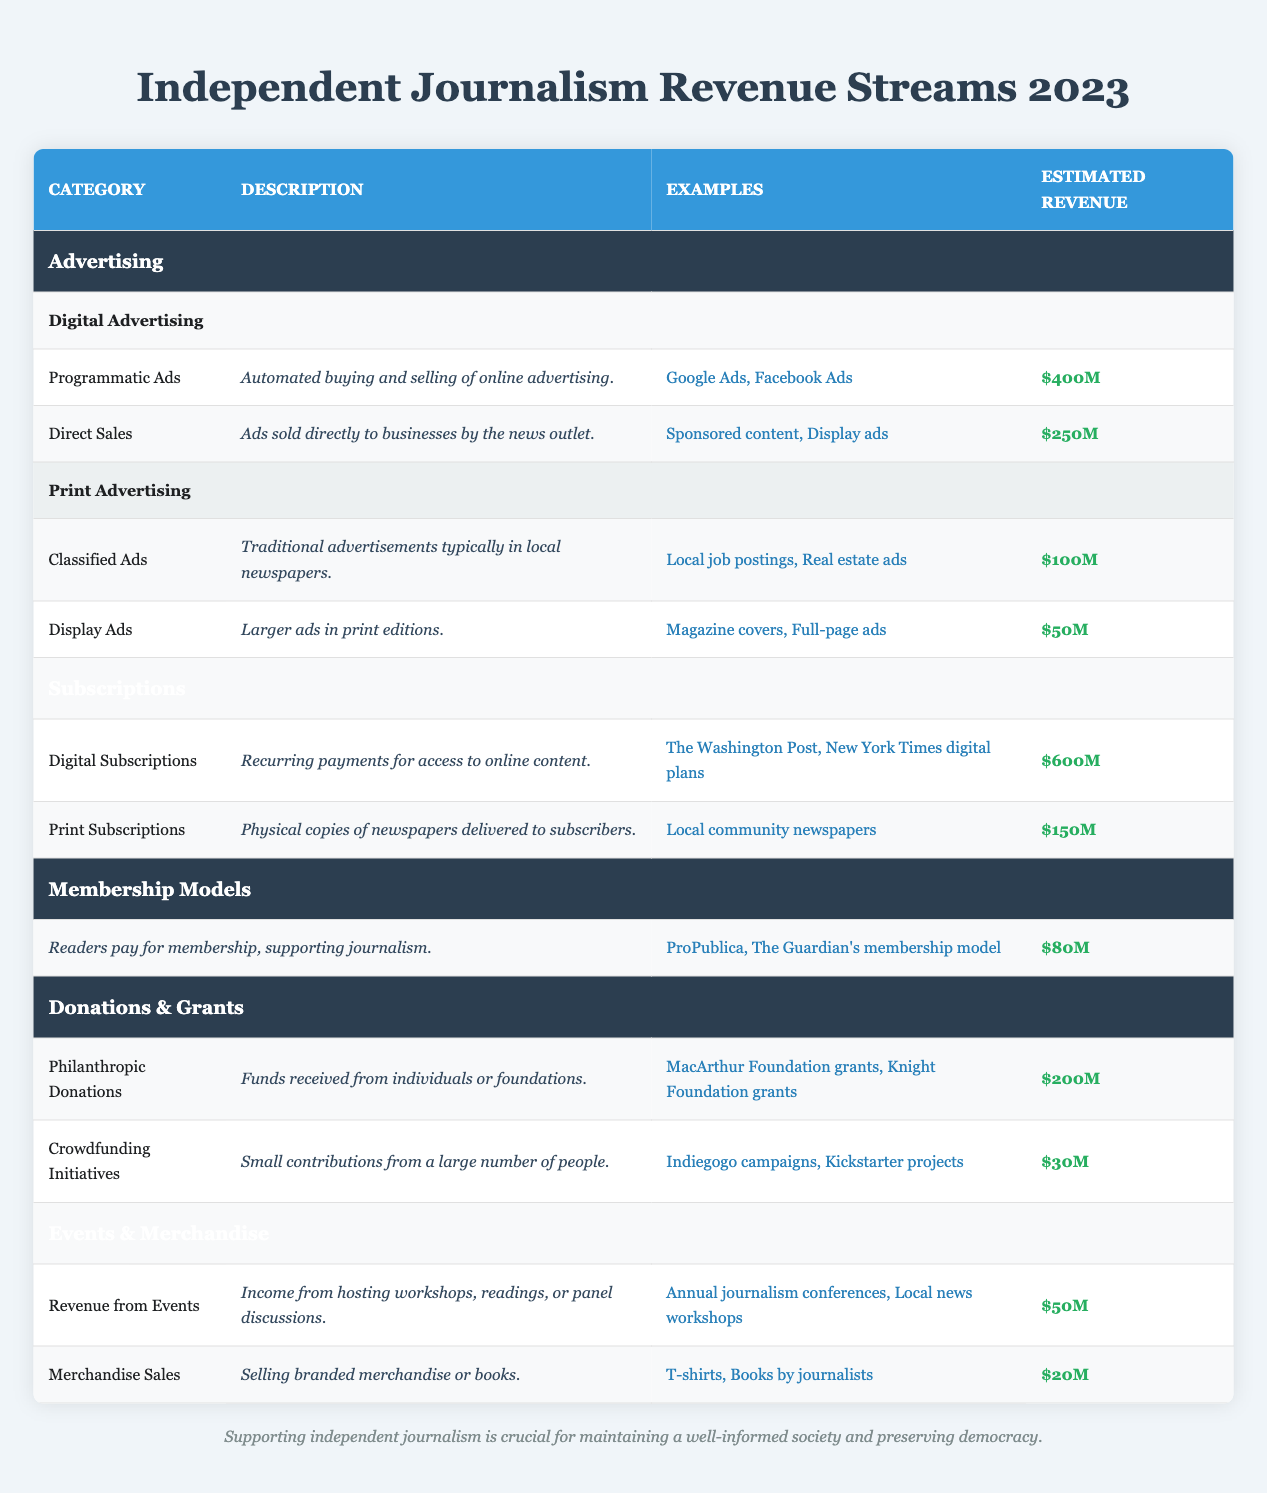What is the estimated revenue from Digital Advertising? The table shows that the estimated revenue from Digital Advertising is divided into Programmatic Ads and Direct Sales. Combining their values: Programmatic Ads = $400M and Direct Sales = $250M. The total for Digital Advertising is $400M + $250M = $650M.
Answer: $650M What type of advertising generates the least revenue? By examining the revenue estimates, we note that Display Ads in Print Advertising generate $50M, which is less than any other advertising category listed.
Answer: Display Ads Which revenue stream has the highest estimated revenue? Looking at the estimated revenues across the categories, Digital Subscriptions has the highest revenue at $600M compared to other streams, which are lower.
Answer: Digital Subscriptions Is the revenue from Print Subscriptions higher than that from Membership Models? The revenue for Print Subscriptions is $150M and for Membership Models is $80M. Since $150M is greater than $80M, the statement is true.
Answer: Yes What is the combined revenue from Donations & Grants? In the Donations & Grants category, there are two streams: Philanthropic Donations ($200M) and Crowdfunding Initiatives ($30M). Their total is calculated as follows: $200M + $30M = $230M.
Answer: $230M How much revenue is generated from Events compared to Merchandise Sales? The revenue for Events is $50M, while Merchandise Sales has $20M. To compare them, $50M is greater than $20M, showing that Events generate more revenue.
Answer: Events generate more revenue What percentage of the total estimated revenue is attributed to Digital Subscriptions? First, calculate the total revenue from all streams. Summing these gives: $650M (Digital Advertising) + $250M (Print Advertising) + $600M (Digital Subscriptions) + $150M (Print Subscriptions) + $80M (Membership Models) + $230M (Donations & Grants) + $70M (Events & Merchandise) = $2.06B. Then calculate the percentage: ($600M / $2.06B) * 100 ≈ 29.1%.
Answer: Approximately 29.1% Which type of crowdfunding initiative has a higher estimated revenue: Indiegogo campaigns or Kickstarter projects? The table states that Crowdfunding Initiatives brings in $30M, but does not specify how much is from Indiegogo campaigns versus Kickstarter projects. Therefore, we cannot conclude which one specifically earns more revenue from this data.
Answer: Insufficient information What type of revenue contributes the most to Advertising as a category? In the Advertising category, Digital Advertising brings in $650M (sum of its two sub-types), while Print Advertising brings in $150M (sum of its two sub-types). Thus, Digital Advertising contributes significantly more to the overall Advertising revenue.
Answer: Digital Advertising 